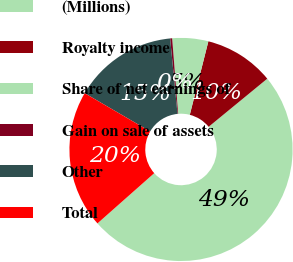Convert chart to OTSL. <chart><loc_0><loc_0><loc_500><loc_500><pie_chart><fcel>(Millions)<fcel>Royalty income<fcel>Share of net earnings of<fcel>Gain on sale of assets<fcel>Other<fcel>Total<nl><fcel>49.41%<fcel>10.12%<fcel>5.21%<fcel>0.29%<fcel>15.03%<fcel>19.94%<nl></chart> 